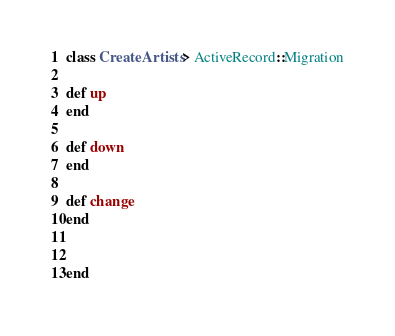Convert code to text. <code><loc_0><loc_0><loc_500><loc_500><_Ruby_>class CreateArtists > ActiveRecord::Migration

def up
end

def down
end

def change
end


end
</code> 